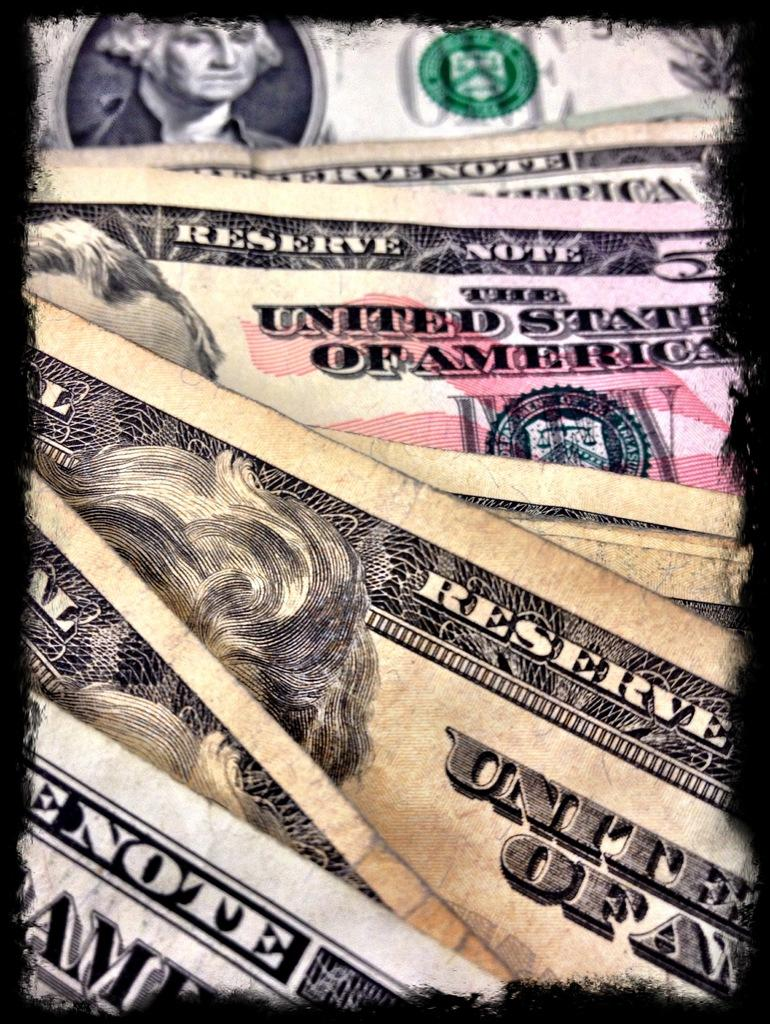What type of objects are present in the image? There are currency notes in the image. How are the currency notes arranged in the image? The currency notes are stacked one above the other. What type of coast can be seen in the image? There is no coast present in the image; it only features currency notes stacked one above the other. 